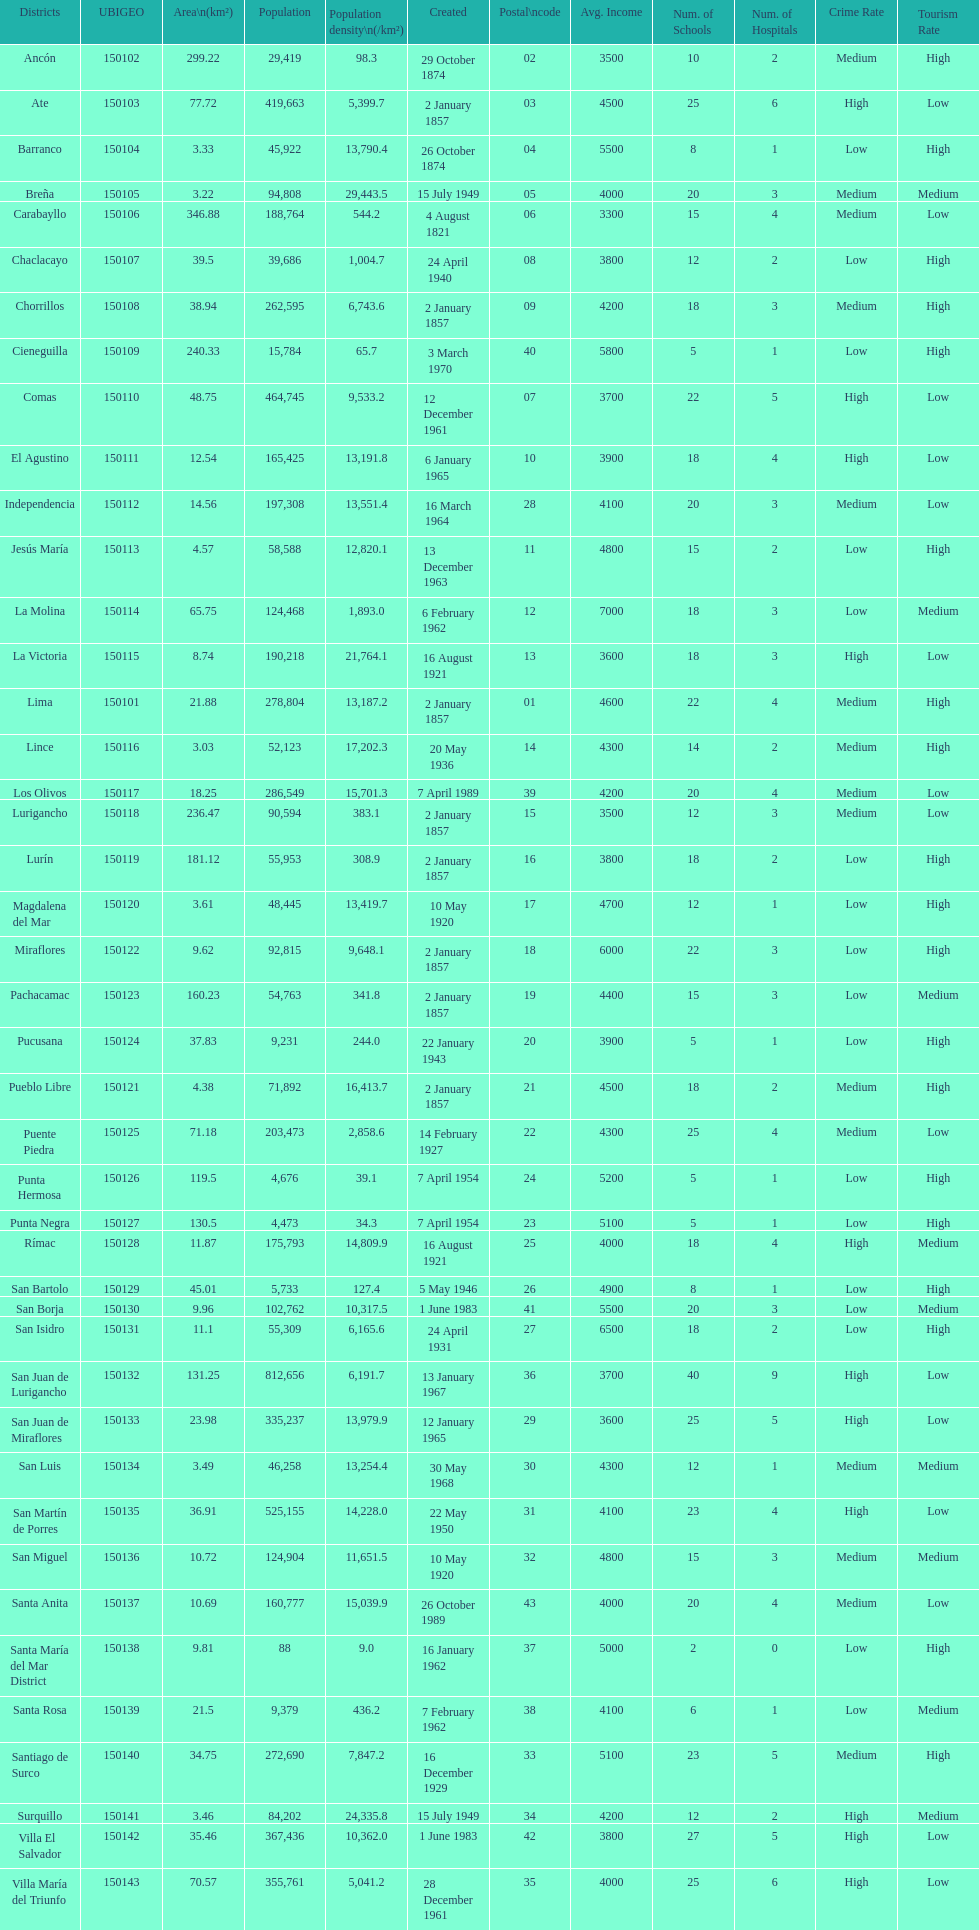Which is the largest district in terms of population? San Juan de Lurigancho. 